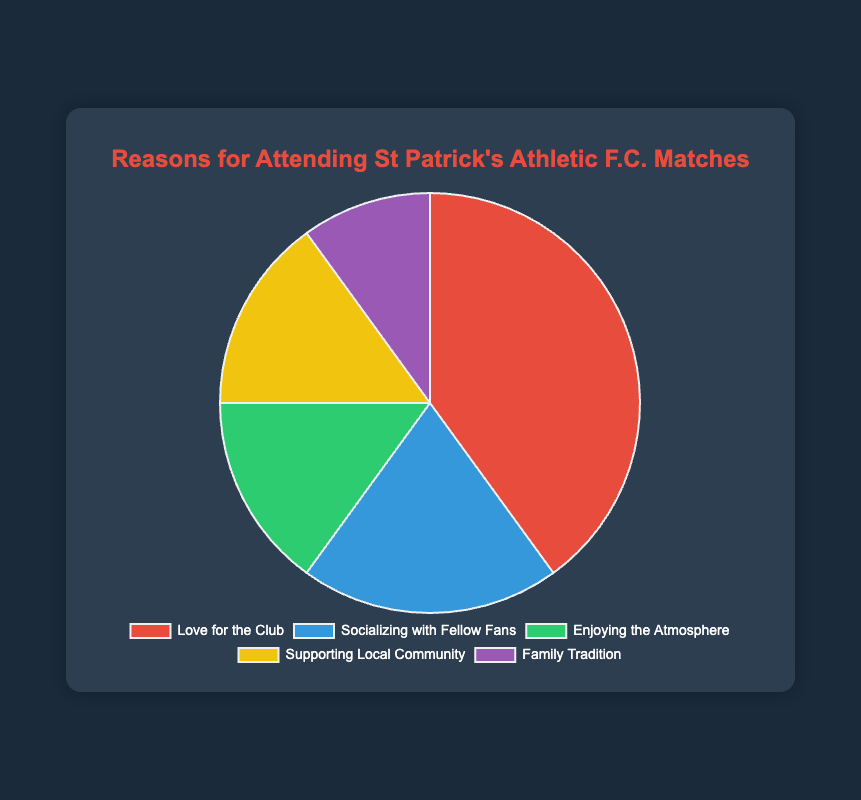What is the most common reason for attending St Patrick's Athletic F.C. matches? The pie chart title suggests reasons for attendance at St Patrick's Athletic F.C. matches. By looking at the largest section of the pie chart, we can see that "Love for the Club" occupies the largest area.
Answer: Love for the Club What percentage of attendees go to matches to support the local community? We need to identify the slice with the label "Supporting Local Community" and read its value, which is marked at 15%.
Answer: 15% Which reason has a smaller percentage than "Socializing with Fellow Fans" but a larger percentage than "Family Tradition"? We compare the percentages for "Socializing with Fellow Fans" (20%) and "Family Tradition" (10%). The reasons between these values are "Enjoying the Atmosphere" (15%) and "Supporting Local Community" (15%). Any of these answers is acceptable as they satisfy the condition.
Answer: Enjoying the Atmosphere/Supporting Local Community What is the percentage difference between "Love for the Club" and "Socializing with Fellow Fans"? Subtract the percentage for "Socializing with Fellow Fans" (20%) from the percentage for "Love for the Club" (40%). The difference is 40% - 20% = 20%.
Answer: 20% If you combine the percentages for "Supporting Local Community" and "Family Tradition," what is the total percentage? Add the percentages for "Supporting Local Community" (15%) and "Family Tradition" (10%). The sum is 15% + 10% = 25%.
Answer: 25% What color represents "Enjoying the Atmosphere" in the pie chart? We need to identify the color of the pie slice labeled "Enjoying the Atmosphere." By observing the color code corresponding to this label, we can see that it is green.
Answer: Green Which two reasons share the same percentage in the data provided? By reviewing the percentages for each reason, we see that "Enjoying the Atmosphere" and "Supporting Local Community" both have a percentage of 15%.
Answer: Enjoying the Atmosphere and Supporting Local Community By how much does the percentage of "Love for the Club" exceed the sum of "Supporting Local Community" and "Family Tradition"? First sum the percentages of "Supporting Local Community" and "Family Tradition": 15% + 10% = 25%. Then subtract this sum from the percentage for "Love for the Club": 40% - 25% = 15%.
Answer: 15% What is the average percentage of all the reasons for attending matches? Add the percentages of all the reasons (40% + 20% + 15% + 15% + 10%) to get 100%, then divide by the number of reasons (5): 100% / 5 = 20%.
Answer: 20% Does "Socializing with Fellow Fans" constitute greater than or less than 1/5 of the total percentage? 1/5 of the total percentage is 20%. Comparing this with "Socializing with Fellow Fans," which is also 20%, we find they are equal.
Answer: Equal 